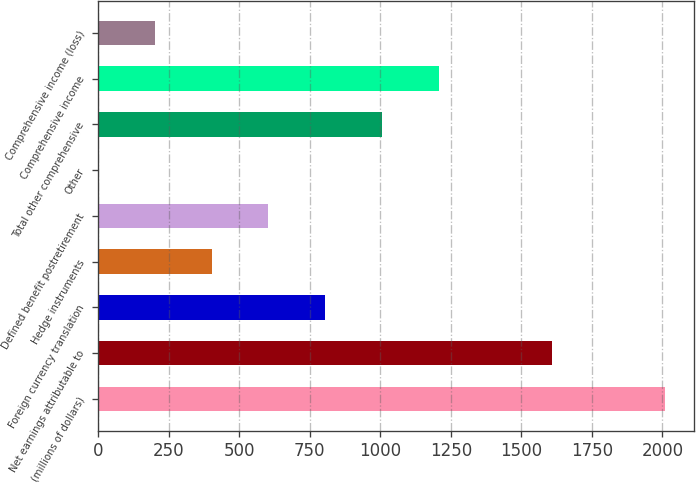Convert chart to OTSL. <chart><loc_0><loc_0><loc_500><loc_500><bar_chart><fcel>(millions of dollars)<fcel>Net earnings attributable to<fcel>Foreign currency translation<fcel>Hedge instruments<fcel>Defined benefit postretirement<fcel>Other<fcel>Total other comprehensive<fcel>Comprehensive income<fcel>Comprehensive income (loss)<nl><fcel>2011<fcel>1608.82<fcel>804.46<fcel>402.28<fcel>603.37<fcel>0.1<fcel>1005.55<fcel>1206.64<fcel>201.19<nl></chart> 